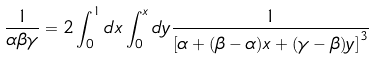Convert formula to latex. <formula><loc_0><loc_0><loc_500><loc_500>\frac { 1 } { \alpha \beta \gamma } = 2 \int _ { 0 } ^ { 1 } d x \int _ { 0 } ^ { x } d y \frac { 1 } { \left [ \alpha + ( \beta - \alpha ) x + ( \gamma - \beta ) y \right ] ^ { 3 } }</formula> 